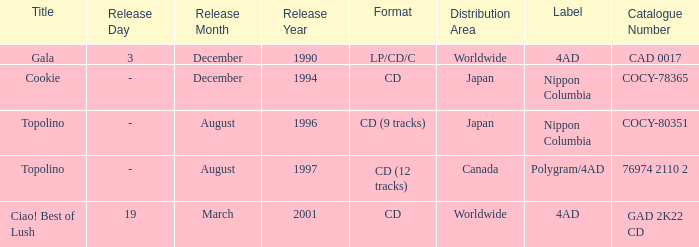Could you help me parse every detail presented in this table? {'header': ['Title', 'Release Day', 'Release Month', 'Release Year', 'Format', 'Distribution Area', 'Label', 'Catalogue Number'], 'rows': [['Gala', '3', 'December', '1990', 'LP/CD/C', 'Worldwide', '4AD', 'CAD 0017'], ['Cookie', '-', 'December', '1994', 'CD', 'Japan', 'Nippon Columbia', 'COCY-78365'], ['Topolino', '-', 'August', '1996', 'CD (9 tracks)', 'Japan', 'Nippon Columbia', 'COCY-80351'], ['Topolino', '-', 'August', '1997', 'CD (12 tracks)', 'Canada', 'Polygram/4AD', '76974 2110 2'], ['Ciao! Best of Lush', '19', 'March', '2001', 'CD', 'Worldwide', '4AD', 'GAD 2K22 CD']]} What Label has a Code of cocy-78365? Nippon Columbia. 